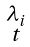<formula> <loc_0><loc_0><loc_500><loc_500>\begin{smallmatrix} \lambda _ { i } \\ t \end{smallmatrix}</formula> 